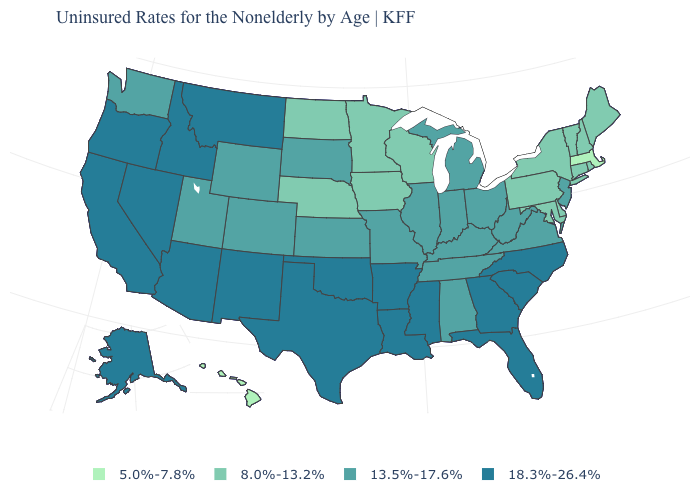Does the map have missing data?
Keep it brief. No. How many symbols are there in the legend?
Be succinct. 4. What is the value of Delaware?
Answer briefly. 8.0%-13.2%. Does Arkansas have the highest value in the USA?
Concise answer only. Yes. Is the legend a continuous bar?
Concise answer only. No. Name the states that have a value in the range 13.5%-17.6%?
Give a very brief answer. Alabama, Colorado, Illinois, Indiana, Kansas, Kentucky, Michigan, Missouri, New Jersey, Ohio, South Dakota, Tennessee, Utah, Virginia, Washington, West Virginia, Wyoming. Name the states that have a value in the range 13.5%-17.6%?
Write a very short answer. Alabama, Colorado, Illinois, Indiana, Kansas, Kentucky, Michigan, Missouri, New Jersey, Ohio, South Dakota, Tennessee, Utah, Virginia, Washington, West Virginia, Wyoming. Name the states that have a value in the range 18.3%-26.4%?
Be succinct. Alaska, Arizona, Arkansas, California, Florida, Georgia, Idaho, Louisiana, Mississippi, Montana, Nevada, New Mexico, North Carolina, Oklahoma, Oregon, South Carolina, Texas. Name the states that have a value in the range 18.3%-26.4%?
Quick response, please. Alaska, Arizona, Arkansas, California, Florida, Georgia, Idaho, Louisiana, Mississippi, Montana, Nevada, New Mexico, North Carolina, Oklahoma, Oregon, South Carolina, Texas. Which states have the highest value in the USA?
Write a very short answer. Alaska, Arizona, Arkansas, California, Florida, Georgia, Idaho, Louisiana, Mississippi, Montana, Nevada, New Mexico, North Carolina, Oklahoma, Oregon, South Carolina, Texas. Name the states that have a value in the range 13.5%-17.6%?
Quick response, please. Alabama, Colorado, Illinois, Indiana, Kansas, Kentucky, Michigan, Missouri, New Jersey, Ohio, South Dakota, Tennessee, Utah, Virginia, Washington, West Virginia, Wyoming. What is the value of Hawaii?
Keep it brief. 5.0%-7.8%. What is the value of Washington?
Keep it brief. 13.5%-17.6%. Name the states that have a value in the range 5.0%-7.8%?
Be succinct. Hawaii, Massachusetts. 